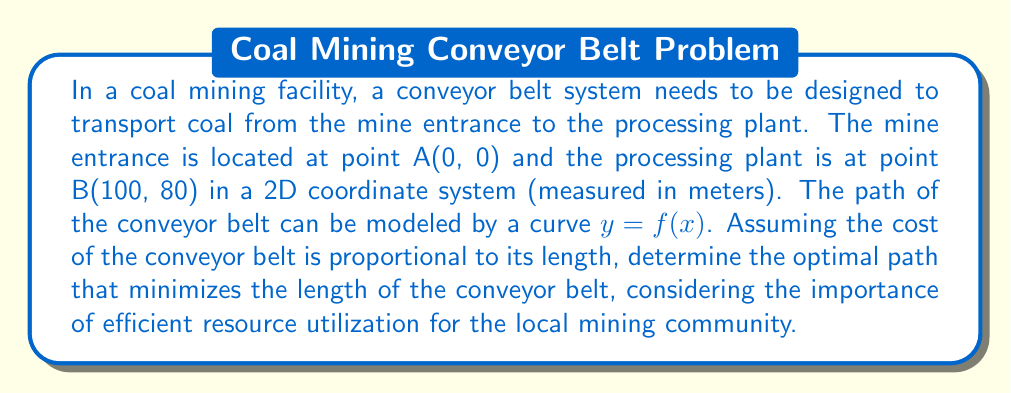Give your solution to this math problem. To find the optimal path that minimizes the length of the conveyor belt, we need to use the principles of calculus of variations. The problem is to minimize the arc length of the curve connecting points A and B.

Step 1: Express the arc length formula
The arc length of a curve $y = f(x)$ from $x = a$ to $x = b$ is given by:

$$L = \int_a^b \sqrt{1 + \left(\frac{dy}{dx}\right)^2} dx$$

Step 2: Set up the Euler-Lagrange equation
The Euler-Lagrange equation for minimizing arc length is:

$$\frac{d}{dx}\left(\frac{\partial F}{\partial y'}\right) - \frac{\partial F}{\partial y} = 0$$

where $F = \sqrt{1 + (y')^2}$

Step 3: Solve the Euler-Lagrange equation
Since $F$ does not depend on $y$ explicitly, we have:

$$\frac{d}{dx}\left(\frac{y'}{\sqrt{1 + (y')^2}}\right) = 0$$

This implies that $\frac{y'}{\sqrt{1 + (y')^2}} = C$ (constant)

Step 4: Simplify and solve for $y'$
$$y' = \frac{C}{\sqrt{1 - C^2}}$$

This is the equation of a straight line with slope $m = \frac{C}{\sqrt{1 - C^2}}$

Step 5: Determine the equation of the line
Using the two points A(0, 0) and B(100, 80), we can find the slope:

$$m = \frac{80 - 0}{100 - 0} = \frac{4}{5} = 0.8$$

The equation of the line is:
$$y = 0.8x$$

Step 6: Calculate the length of the optimal path
The length of the straight line can be calculated using the distance formula:

$$L = \sqrt{(x_2 - x_1)^2 + (y_2 - y_1)^2} = \sqrt{100^2 + 80^2} = \sqrt{16400} = 128 \text{ meters}$$

This straight line represents the optimal path for the conveyor belt, minimizing its length and thus the cost of construction and maintenance. This solution aligns with the goal of efficient resource utilization, which is crucial for the economic sustainability of the local mining community.
Answer: A straight line path $y = 0.8x$ with length 128 meters. 